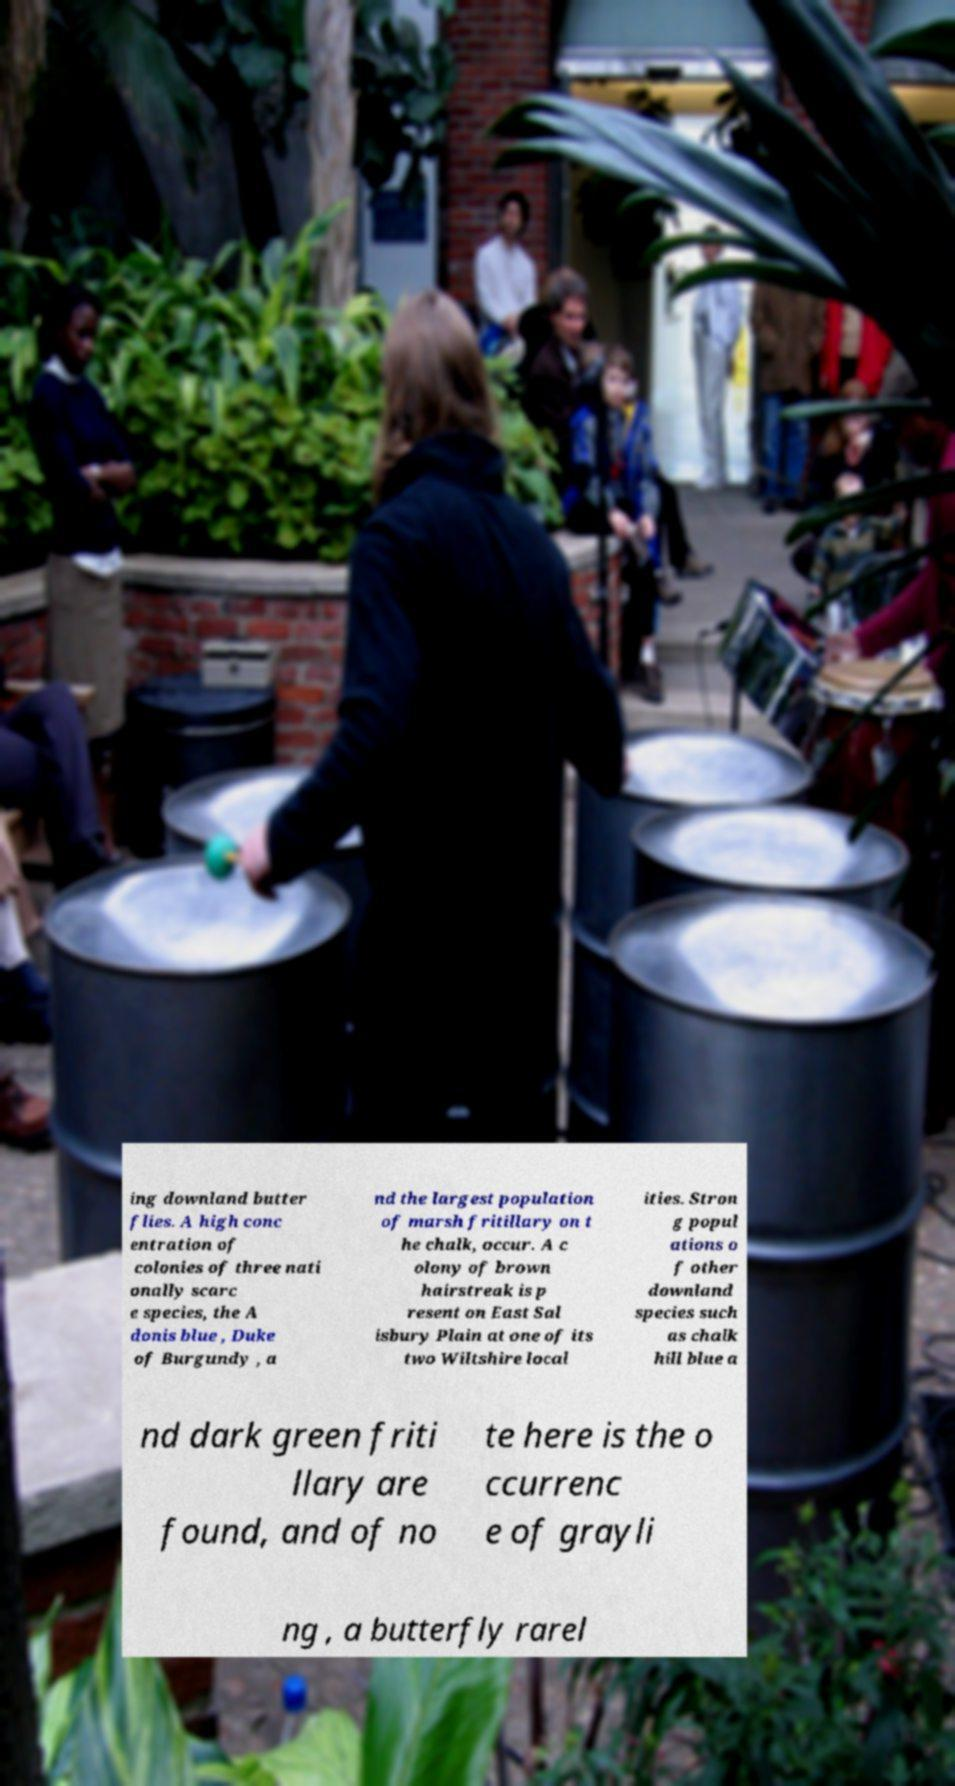I need the written content from this picture converted into text. Can you do that? ing downland butter flies. A high conc entration of colonies of three nati onally scarc e species, the A donis blue , Duke of Burgundy , a nd the largest population of marsh fritillary on t he chalk, occur. A c olony of brown hairstreak is p resent on East Sal isbury Plain at one of its two Wiltshire local ities. Stron g popul ations o f other downland species such as chalk hill blue a nd dark green friti llary are found, and of no te here is the o ccurrenc e of grayli ng , a butterfly rarel 